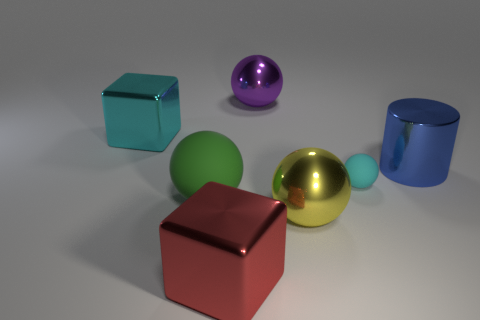Add 1 purple metallic cylinders. How many objects exist? 8 Subtract all blocks. How many objects are left? 5 Subtract 1 purple spheres. How many objects are left? 6 Subtract all cyan shiny objects. Subtract all rubber spheres. How many objects are left? 4 Add 4 cyan rubber things. How many cyan rubber things are left? 5 Add 4 yellow rubber cylinders. How many yellow rubber cylinders exist? 4 